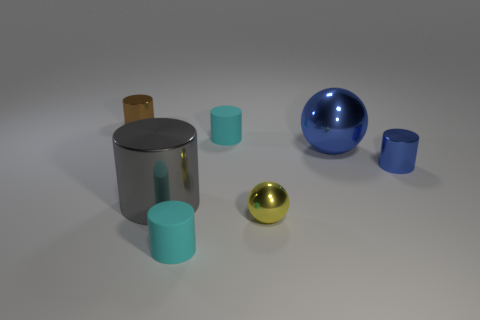What material is the tiny yellow thing that is the same shape as the big blue metallic thing?
Your answer should be very brief. Metal. There is a large sphere; is its color the same as the metallic cylinder to the right of the large metal cylinder?
Offer a terse response. Yes. There is a large object on the right side of the cyan cylinder that is in front of the big gray metallic thing; what is its color?
Keep it short and to the point. Blue. Are there any rubber cylinders left of the small yellow metallic object behind the tiny cyan object in front of the blue ball?
Your response must be concise. Yes. There is another ball that is the same material as the small yellow sphere; what color is it?
Keep it short and to the point. Blue. How many small brown objects have the same material as the tiny ball?
Offer a very short reply. 1. Does the brown cylinder have the same material as the cyan object that is in front of the large gray shiny cylinder?
Make the answer very short. No. What number of objects are either small cylinders in front of the tiny brown shiny cylinder or big metal objects?
Offer a very short reply. 5. There is a cyan matte cylinder that is behind the small metal cylinder in front of the tiny metallic thing left of the tiny yellow metal ball; how big is it?
Give a very brief answer. Small. What is the size of the object behind the small cyan matte cylinder behind the tiny metallic ball?
Give a very brief answer. Small. 